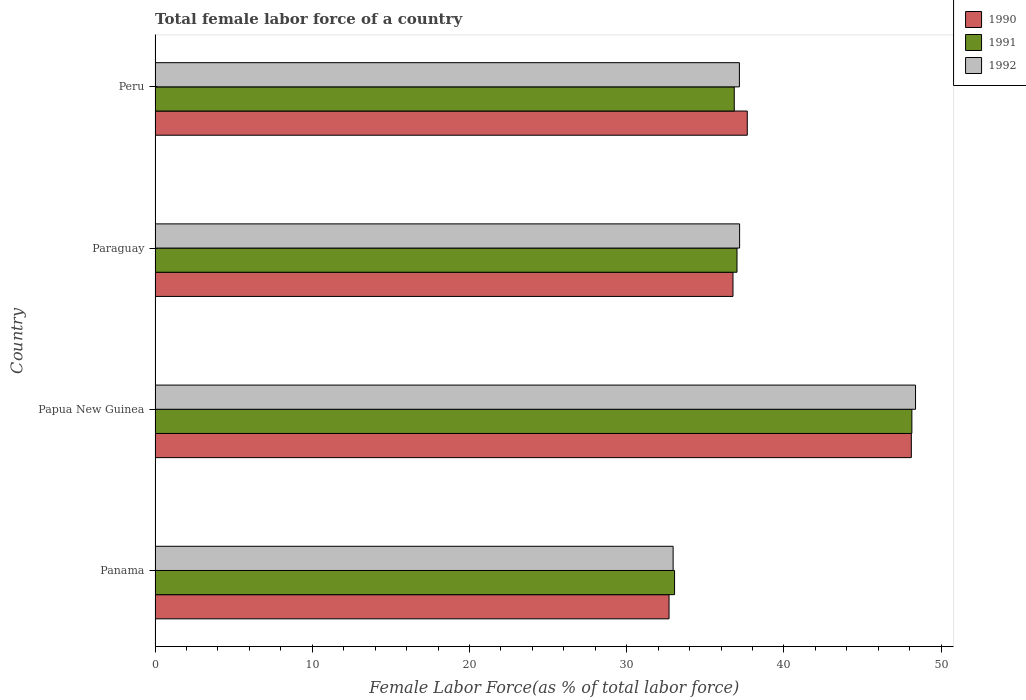Are the number of bars per tick equal to the number of legend labels?
Ensure brevity in your answer.  Yes. Are the number of bars on each tick of the Y-axis equal?
Keep it short and to the point. Yes. How many bars are there on the 4th tick from the top?
Your answer should be compact. 3. What is the label of the 2nd group of bars from the top?
Your answer should be compact. Paraguay. In how many cases, is the number of bars for a given country not equal to the number of legend labels?
Your response must be concise. 0. What is the percentage of female labor force in 1991 in Panama?
Your answer should be very brief. 33.04. Across all countries, what is the maximum percentage of female labor force in 1992?
Give a very brief answer. 48.37. Across all countries, what is the minimum percentage of female labor force in 1990?
Offer a terse response. 32.69. In which country was the percentage of female labor force in 1990 maximum?
Give a very brief answer. Papua New Guinea. In which country was the percentage of female labor force in 1990 minimum?
Give a very brief answer. Panama. What is the total percentage of female labor force in 1991 in the graph?
Your answer should be compact. 155.02. What is the difference between the percentage of female labor force in 1990 in Papua New Guinea and that in Paraguay?
Make the answer very short. 11.34. What is the difference between the percentage of female labor force in 1990 in Panama and the percentage of female labor force in 1991 in Papua New Guinea?
Your response must be concise. -15.44. What is the average percentage of female labor force in 1991 per country?
Offer a very short reply. 38.76. What is the difference between the percentage of female labor force in 1991 and percentage of female labor force in 1992 in Peru?
Offer a very short reply. -0.33. In how many countries, is the percentage of female labor force in 1992 greater than 40 %?
Your response must be concise. 1. What is the ratio of the percentage of female labor force in 1992 in Papua New Guinea to that in Peru?
Give a very brief answer. 1.3. Is the difference between the percentage of female labor force in 1991 in Papua New Guinea and Paraguay greater than the difference between the percentage of female labor force in 1992 in Papua New Guinea and Paraguay?
Provide a succinct answer. No. What is the difference between the highest and the second highest percentage of female labor force in 1990?
Make the answer very short. 10.43. What is the difference between the highest and the lowest percentage of female labor force in 1991?
Ensure brevity in your answer.  15.09. Is the sum of the percentage of female labor force in 1990 in Panama and Papua New Guinea greater than the maximum percentage of female labor force in 1991 across all countries?
Make the answer very short. Yes. Are all the bars in the graph horizontal?
Provide a short and direct response. Yes. How many countries are there in the graph?
Provide a short and direct response. 4. Are the values on the major ticks of X-axis written in scientific E-notation?
Provide a short and direct response. No. Where does the legend appear in the graph?
Your response must be concise. Top right. What is the title of the graph?
Ensure brevity in your answer.  Total female labor force of a country. What is the label or title of the X-axis?
Provide a short and direct response. Female Labor Force(as % of total labor force). What is the Female Labor Force(as % of total labor force) of 1990 in Panama?
Your answer should be very brief. 32.69. What is the Female Labor Force(as % of total labor force) in 1991 in Panama?
Your response must be concise. 33.04. What is the Female Labor Force(as % of total labor force) of 1992 in Panama?
Give a very brief answer. 32.95. What is the Female Labor Force(as % of total labor force) in 1990 in Papua New Guinea?
Your answer should be very brief. 48.1. What is the Female Labor Force(as % of total labor force) in 1991 in Papua New Guinea?
Your response must be concise. 48.13. What is the Female Labor Force(as % of total labor force) of 1992 in Papua New Guinea?
Your response must be concise. 48.37. What is the Female Labor Force(as % of total labor force) of 1990 in Paraguay?
Your response must be concise. 36.76. What is the Female Labor Force(as % of total labor force) in 1991 in Paraguay?
Ensure brevity in your answer.  37.01. What is the Female Labor Force(as % of total labor force) in 1992 in Paraguay?
Offer a very short reply. 37.18. What is the Female Labor Force(as % of total labor force) in 1990 in Peru?
Offer a very short reply. 37.67. What is the Female Labor Force(as % of total labor force) of 1991 in Peru?
Make the answer very short. 36.84. What is the Female Labor Force(as % of total labor force) of 1992 in Peru?
Give a very brief answer. 37.16. Across all countries, what is the maximum Female Labor Force(as % of total labor force) in 1990?
Keep it short and to the point. 48.1. Across all countries, what is the maximum Female Labor Force(as % of total labor force) in 1991?
Your response must be concise. 48.13. Across all countries, what is the maximum Female Labor Force(as % of total labor force) of 1992?
Ensure brevity in your answer.  48.37. Across all countries, what is the minimum Female Labor Force(as % of total labor force) of 1990?
Your answer should be very brief. 32.69. Across all countries, what is the minimum Female Labor Force(as % of total labor force) in 1991?
Ensure brevity in your answer.  33.04. Across all countries, what is the minimum Female Labor Force(as % of total labor force) in 1992?
Provide a succinct answer. 32.95. What is the total Female Labor Force(as % of total labor force) of 1990 in the graph?
Offer a terse response. 155.21. What is the total Female Labor Force(as % of total labor force) in 1991 in the graph?
Ensure brevity in your answer.  155.02. What is the total Female Labor Force(as % of total labor force) in 1992 in the graph?
Your answer should be compact. 155.66. What is the difference between the Female Labor Force(as % of total labor force) in 1990 in Panama and that in Papua New Guinea?
Make the answer very short. -15.41. What is the difference between the Female Labor Force(as % of total labor force) of 1991 in Panama and that in Papua New Guinea?
Offer a very short reply. -15.09. What is the difference between the Female Labor Force(as % of total labor force) of 1992 in Panama and that in Papua New Guinea?
Offer a very short reply. -15.42. What is the difference between the Female Labor Force(as % of total labor force) of 1990 in Panama and that in Paraguay?
Make the answer very short. -4.07. What is the difference between the Female Labor Force(as % of total labor force) in 1991 in Panama and that in Paraguay?
Ensure brevity in your answer.  -3.97. What is the difference between the Female Labor Force(as % of total labor force) of 1992 in Panama and that in Paraguay?
Provide a short and direct response. -4.23. What is the difference between the Female Labor Force(as % of total labor force) of 1990 in Panama and that in Peru?
Give a very brief answer. -4.98. What is the difference between the Female Labor Force(as % of total labor force) of 1991 in Panama and that in Peru?
Offer a terse response. -3.8. What is the difference between the Female Labor Force(as % of total labor force) of 1992 in Panama and that in Peru?
Keep it short and to the point. -4.22. What is the difference between the Female Labor Force(as % of total labor force) of 1990 in Papua New Guinea and that in Paraguay?
Offer a very short reply. 11.34. What is the difference between the Female Labor Force(as % of total labor force) in 1991 in Papua New Guinea and that in Paraguay?
Ensure brevity in your answer.  11.12. What is the difference between the Female Labor Force(as % of total labor force) of 1992 in Papua New Guinea and that in Paraguay?
Provide a succinct answer. 11.19. What is the difference between the Female Labor Force(as % of total labor force) of 1990 in Papua New Guinea and that in Peru?
Offer a very short reply. 10.43. What is the difference between the Female Labor Force(as % of total labor force) in 1991 in Papua New Guinea and that in Peru?
Offer a very short reply. 11.3. What is the difference between the Female Labor Force(as % of total labor force) of 1992 in Papua New Guinea and that in Peru?
Provide a short and direct response. 11.2. What is the difference between the Female Labor Force(as % of total labor force) of 1990 in Paraguay and that in Peru?
Give a very brief answer. -0.91. What is the difference between the Female Labor Force(as % of total labor force) in 1991 in Paraguay and that in Peru?
Your answer should be very brief. 0.17. What is the difference between the Female Labor Force(as % of total labor force) of 1992 in Paraguay and that in Peru?
Keep it short and to the point. 0.01. What is the difference between the Female Labor Force(as % of total labor force) in 1990 in Panama and the Female Labor Force(as % of total labor force) in 1991 in Papua New Guinea?
Offer a very short reply. -15.44. What is the difference between the Female Labor Force(as % of total labor force) of 1990 in Panama and the Female Labor Force(as % of total labor force) of 1992 in Papua New Guinea?
Your answer should be compact. -15.68. What is the difference between the Female Labor Force(as % of total labor force) of 1991 in Panama and the Female Labor Force(as % of total labor force) of 1992 in Papua New Guinea?
Make the answer very short. -15.33. What is the difference between the Female Labor Force(as % of total labor force) of 1990 in Panama and the Female Labor Force(as % of total labor force) of 1991 in Paraguay?
Keep it short and to the point. -4.32. What is the difference between the Female Labor Force(as % of total labor force) in 1990 in Panama and the Female Labor Force(as % of total labor force) in 1992 in Paraguay?
Offer a very short reply. -4.49. What is the difference between the Female Labor Force(as % of total labor force) in 1991 in Panama and the Female Labor Force(as % of total labor force) in 1992 in Paraguay?
Offer a terse response. -4.14. What is the difference between the Female Labor Force(as % of total labor force) in 1990 in Panama and the Female Labor Force(as % of total labor force) in 1991 in Peru?
Your response must be concise. -4.15. What is the difference between the Female Labor Force(as % of total labor force) in 1990 in Panama and the Female Labor Force(as % of total labor force) in 1992 in Peru?
Your answer should be very brief. -4.48. What is the difference between the Female Labor Force(as % of total labor force) of 1991 in Panama and the Female Labor Force(as % of total labor force) of 1992 in Peru?
Provide a succinct answer. -4.12. What is the difference between the Female Labor Force(as % of total labor force) in 1990 in Papua New Guinea and the Female Labor Force(as % of total labor force) in 1991 in Paraguay?
Offer a very short reply. 11.09. What is the difference between the Female Labor Force(as % of total labor force) in 1990 in Papua New Guinea and the Female Labor Force(as % of total labor force) in 1992 in Paraguay?
Your response must be concise. 10.92. What is the difference between the Female Labor Force(as % of total labor force) of 1991 in Papua New Guinea and the Female Labor Force(as % of total labor force) of 1992 in Paraguay?
Your answer should be compact. 10.96. What is the difference between the Female Labor Force(as % of total labor force) of 1990 in Papua New Guinea and the Female Labor Force(as % of total labor force) of 1991 in Peru?
Provide a succinct answer. 11.26. What is the difference between the Female Labor Force(as % of total labor force) of 1990 in Papua New Guinea and the Female Labor Force(as % of total labor force) of 1992 in Peru?
Make the answer very short. 10.93. What is the difference between the Female Labor Force(as % of total labor force) of 1991 in Papua New Guinea and the Female Labor Force(as % of total labor force) of 1992 in Peru?
Provide a succinct answer. 10.97. What is the difference between the Female Labor Force(as % of total labor force) of 1990 in Paraguay and the Female Labor Force(as % of total labor force) of 1991 in Peru?
Your response must be concise. -0.08. What is the difference between the Female Labor Force(as % of total labor force) of 1990 in Paraguay and the Female Labor Force(as % of total labor force) of 1992 in Peru?
Ensure brevity in your answer.  -0.41. What is the difference between the Female Labor Force(as % of total labor force) of 1991 in Paraguay and the Female Labor Force(as % of total labor force) of 1992 in Peru?
Offer a terse response. -0.15. What is the average Female Labor Force(as % of total labor force) in 1990 per country?
Provide a short and direct response. 38.8. What is the average Female Labor Force(as % of total labor force) in 1991 per country?
Your response must be concise. 38.76. What is the average Female Labor Force(as % of total labor force) in 1992 per country?
Your answer should be very brief. 38.91. What is the difference between the Female Labor Force(as % of total labor force) of 1990 and Female Labor Force(as % of total labor force) of 1991 in Panama?
Provide a short and direct response. -0.35. What is the difference between the Female Labor Force(as % of total labor force) of 1990 and Female Labor Force(as % of total labor force) of 1992 in Panama?
Keep it short and to the point. -0.26. What is the difference between the Female Labor Force(as % of total labor force) of 1991 and Female Labor Force(as % of total labor force) of 1992 in Panama?
Your response must be concise. 0.09. What is the difference between the Female Labor Force(as % of total labor force) in 1990 and Female Labor Force(as % of total labor force) in 1991 in Papua New Guinea?
Provide a succinct answer. -0.04. What is the difference between the Female Labor Force(as % of total labor force) in 1990 and Female Labor Force(as % of total labor force) in 1992 in Papua New Guinea?
Give a very brief answer. -0.27. What is the difference between the Female Labor Force(as % of total labor force) of 1991 and Female Labor Force(as % of total labor force) of 1992 in Papua New Guinea?
Your response must be concise. -0.23. What is the difference between the Female Labor Force(as % of total labor force) of 1990 and Female Labor Force(as % of total labor force) of 1991 in Paraguay?
Keep it short and to the point. -0.26. What is the difference between the Female Labor Force(as % of total labor force) of 1990 and Female Labor Force(as % of total labor force) of 1992 in Paraguay?
Your answer should be very brief. -0.42. What is the difference between the Female Labor Force(as % of total labor force) in 1991 and Female Labor Force(as % of total labor force) in 1992 in Paraguay?
Provide a succinct answer. -0.17. What is the difference between the Female Labor Force(as % of total labor force) of 1990 and Female Labor Force(as % of total labor force) of 1991 in Peru?
Your answer should be very brief. 0.83. What is the difference between the Female Labor Force(as % of total labor force) in 1990 and Female Labor Force(as % of total labor force) in 1992 in Peru?
Offer a very short reply. 0.5. What is the difference between the Female Labor Force(as % of total labor force) of 1991 and Female Labor Force(as % of total labor force) of 1992 in Peru?
Ensure brevity in your answer.  -0.33. What is the ratio of the Female Labor Force(as % of total labor force) of 1990 in Panama to that in Papua New Guinea?
Provide a short and direct response. 0.68. What is the ratio of the Female Labor Force(as % of total labor force) of 1991 in Panama to that in Papua New Guinea?
Your answer should be very brief. 0.69. What is the ratio of the Female Labor Force(as % of total labor force) in 1992 in Panama to that in Papua New Guinea?
Offer a terse response. 0.68. What is the ratio of the Female Labor Force(as % of total labor force) in 1990 in Panama to that in Paraguay?
Provide a short and direct response. 0.89. What is the ratio of the Female Labor Force(as % of total labor force) of 1991 in Panama to that in Paraguay?
Offer a very short reply. 0.89. What is the ratio of the Female Labor Force(as % of total labor force) in 1992 in Panama to that in Paraguay?
Keep it short and to the point. 0.89. What is the ratio of the Female Labor Force(as % of total labor force) of 1990 in Panama to that in Peru?
Provide a short and direct response. 0.87. What is the ratio of the Female Labor Force(as % of total labor force) in 1991 in Panama to that in Peru?
Your answer should be compact. 0.9. What is the ratio of the Female Labor Force(as % of total labor force) of 1992 in Panama to that in Peru?
Your answer should be compact. 0.89. What is the ratio of the Female Labor Force(as % of total labor force) in 1990 in Papua New Guinea to that in Paraguay?
Offer a terse response. 1.31. What is the ratio of the Female Labor Force(as % of total labor force) in 1991 in Papua New Guinea to that in Paraguay?
Offer a terse response. 1.3. What is the ratio of the Female Labor Force(as % of total labor force) in 1992 in Papua New Guinea to that in Paraguay?
Offer a terse response. 1.3. What is the ratio of the Female Labor Force(as % of total labor force) of 1990 in Papua New Guinea to that in Peru?
Provide a succinct answer. 1.28. What is the ratio of the Female Labor Force(as % of total labor force) in 1991 in Papua New Guinea to that in Peru?
Give a very brief answer. 1.31. What is the ratio of the Female Labor Force(as % of total labor force) of 1992 in Papua New Guinea to that in Peru?
Ensure brevity in your answer.  1.3. What is the ratio of the Female Labor Force(as % of total labor force) of 1990 in Paraguay to that in Peru?
Provide a short and direct response. 0.98. What is the ratio of the Female Labor Force(as % of total labor force) of 1991 in Paraguay to that in Peru?
Your answer should be compact. 1. What is the ratio of the Female Labor Force(as % of total labor force) of 1992 in Paraguay to that in Peru?
Make the answer very short. 1. What is the difference between the highest and the second highest Female Labor Force(as % of total labor force) of 1990?
Ensure brevity in your answer.  10.43. What is the difference between the highest and the second highest Female Labor Force(as % of total labor force) in 1991?
Make the answer very short. 11.12. What is the difference between the highest and the second highest Female Labor Force(as % of total labor force) of 1992?
Your response must be concise. 11.19. What is the difference between the highest and the lowest Female Labor Force(as % of total labor force) of 1990?
Offer a terse response. 15.41. What is the difference between the highest and the lowest Female Labor Force(as % of total labor force) in 1991?
Ensure brevity in your answer.  15.09. What is the difference between the highest and the lowest Female Labor Force(as % of total labor force) in 1992?
Your response must be concise. 15.42. 